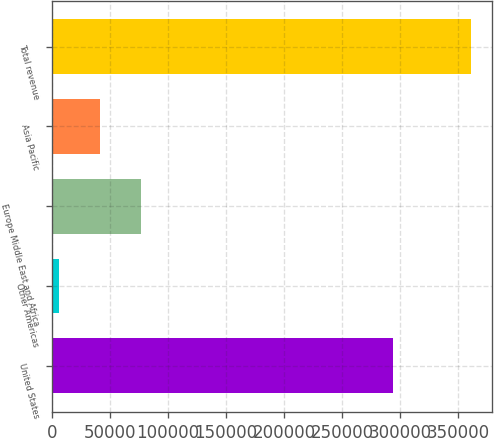Convert chart. <chart><loc_0><loc_0><loc_500><loc_500><bar_chart><fcel>United States<fcel>Other Americas<fcel>Europe Middle East and Africa<fcel>Asia Pacific<fcel>Total revenue<nl><fcel>293579<fcel>6040<fcel>77076.8<fcel>41558.4<fcel>361224<nl></chart> 